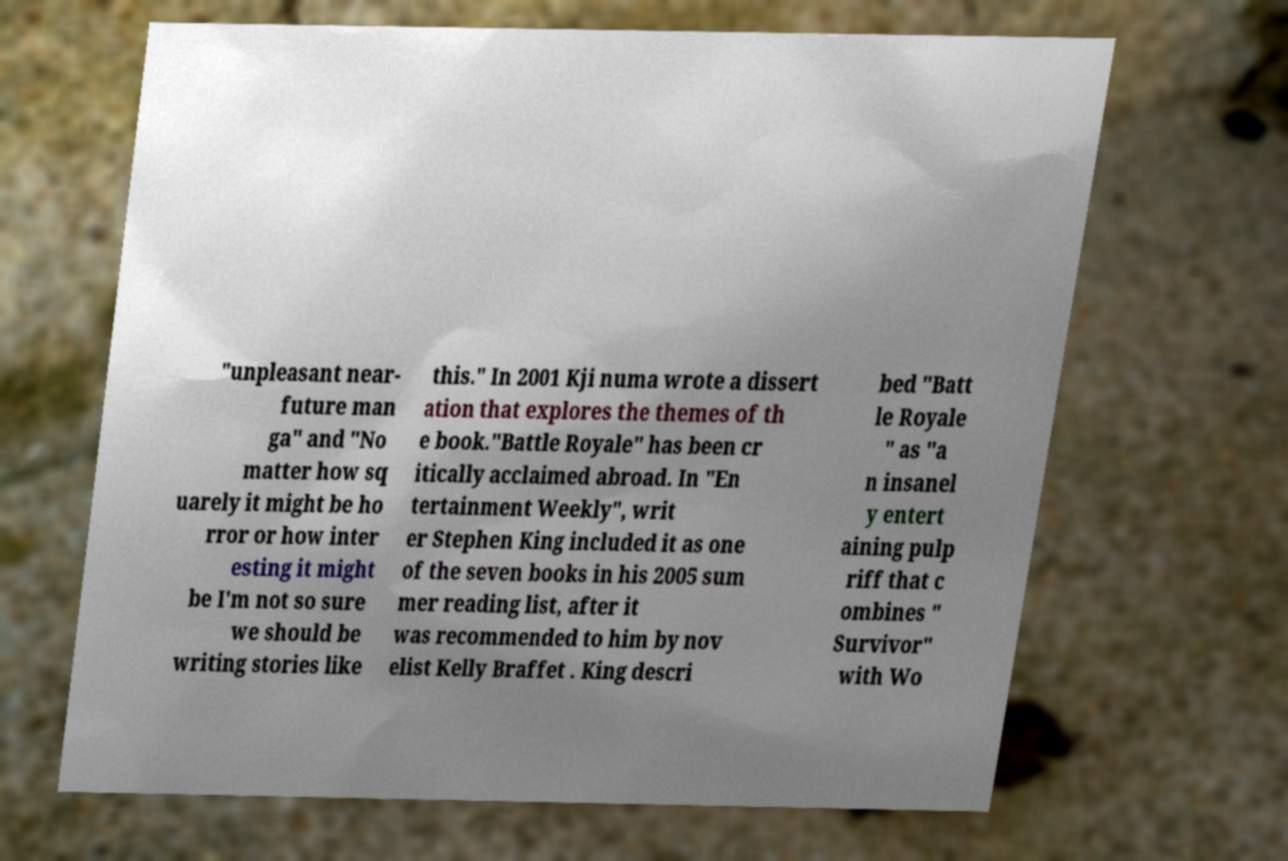Could you assist in decoding the text presented in this image and type it out clearly? "unpleasant near- future man ga" and "No matter how sq uarely it might be ho rror or how inter esting it might be I'm not so sure we should be writing stories like this." In 2001 Kji numa wrote a dissert ation that explores the themes of th e book."Battle Royale" has been cr itically acclaimed abroad. In "En tertainment Weekly", writ er Stephen King included it as one of the seven books in his 2005 sum mer reading list, after it was recommended to him by nov elist Kelly Braffet . King descri bed "Batt le Royale " as "a n insanel y entert aining pulp riff that c ombines " Survivor" with Wo 